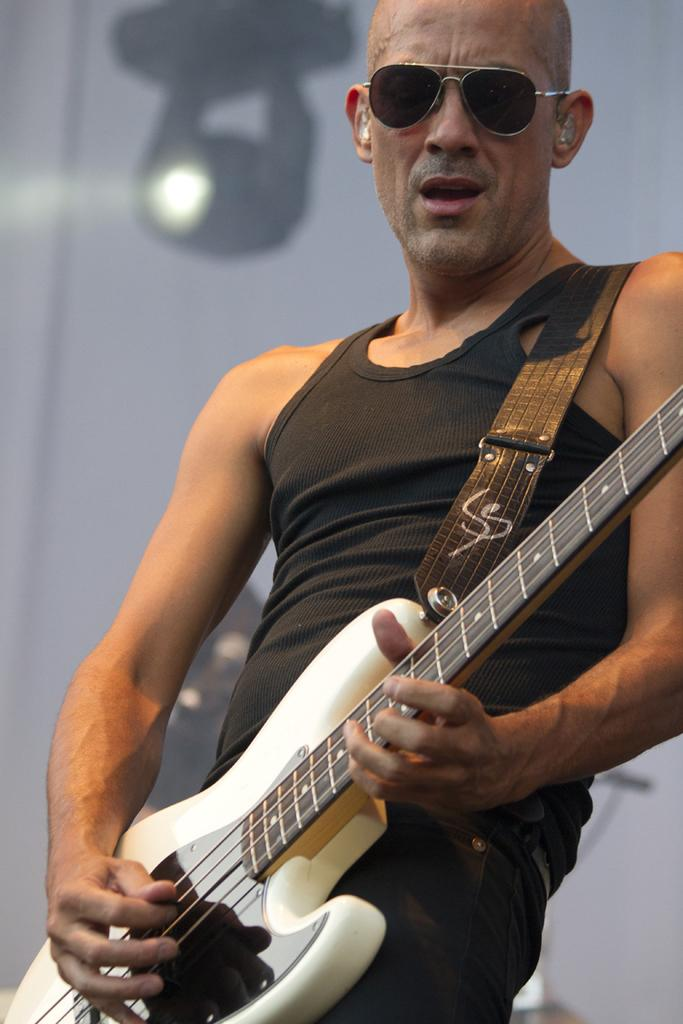What is the man in the image doing? The man is playing a guitar in the image. What is the man wearing while playing the guitar? The man is wearing a black color vest and black color goggles. Can you describe the lighting in the image? There is a light in the background of the image. What type of sock is the man wearing in the image? There is no sock visible in the image; the man is wearing black color goggles and a vest. Is the man wearing a veil in the image? No, the man is not wearing a veil in the image; he is wearing black color goggles and a vest. 